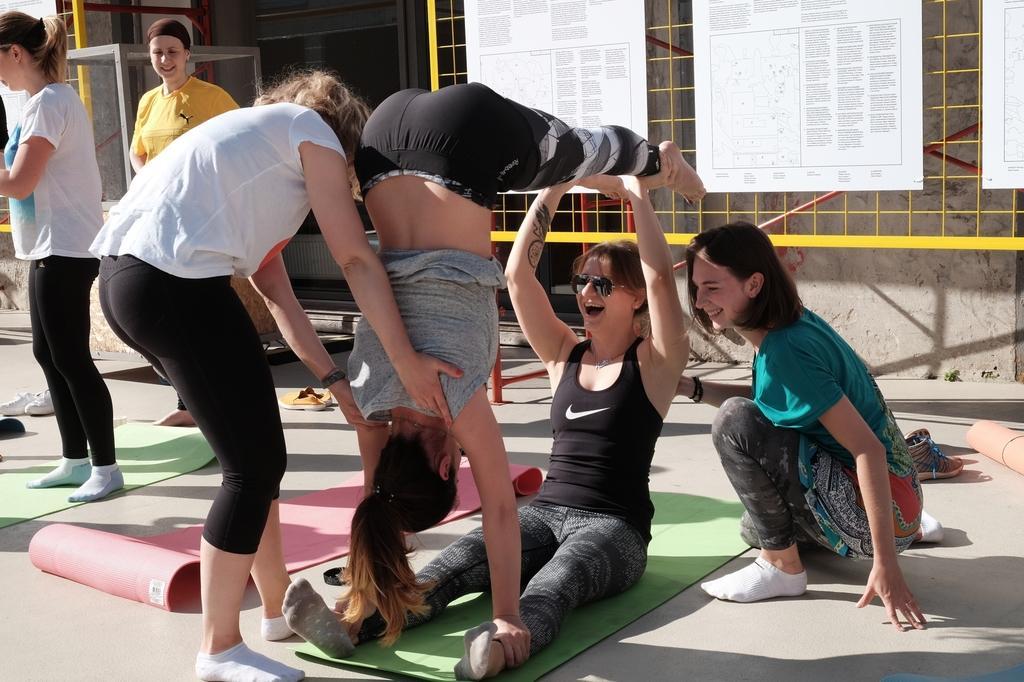Please provide a concise description of this image. In this picture we can see a group of people, mats, footwear on the floor and in the background we can see boards, some objects. 